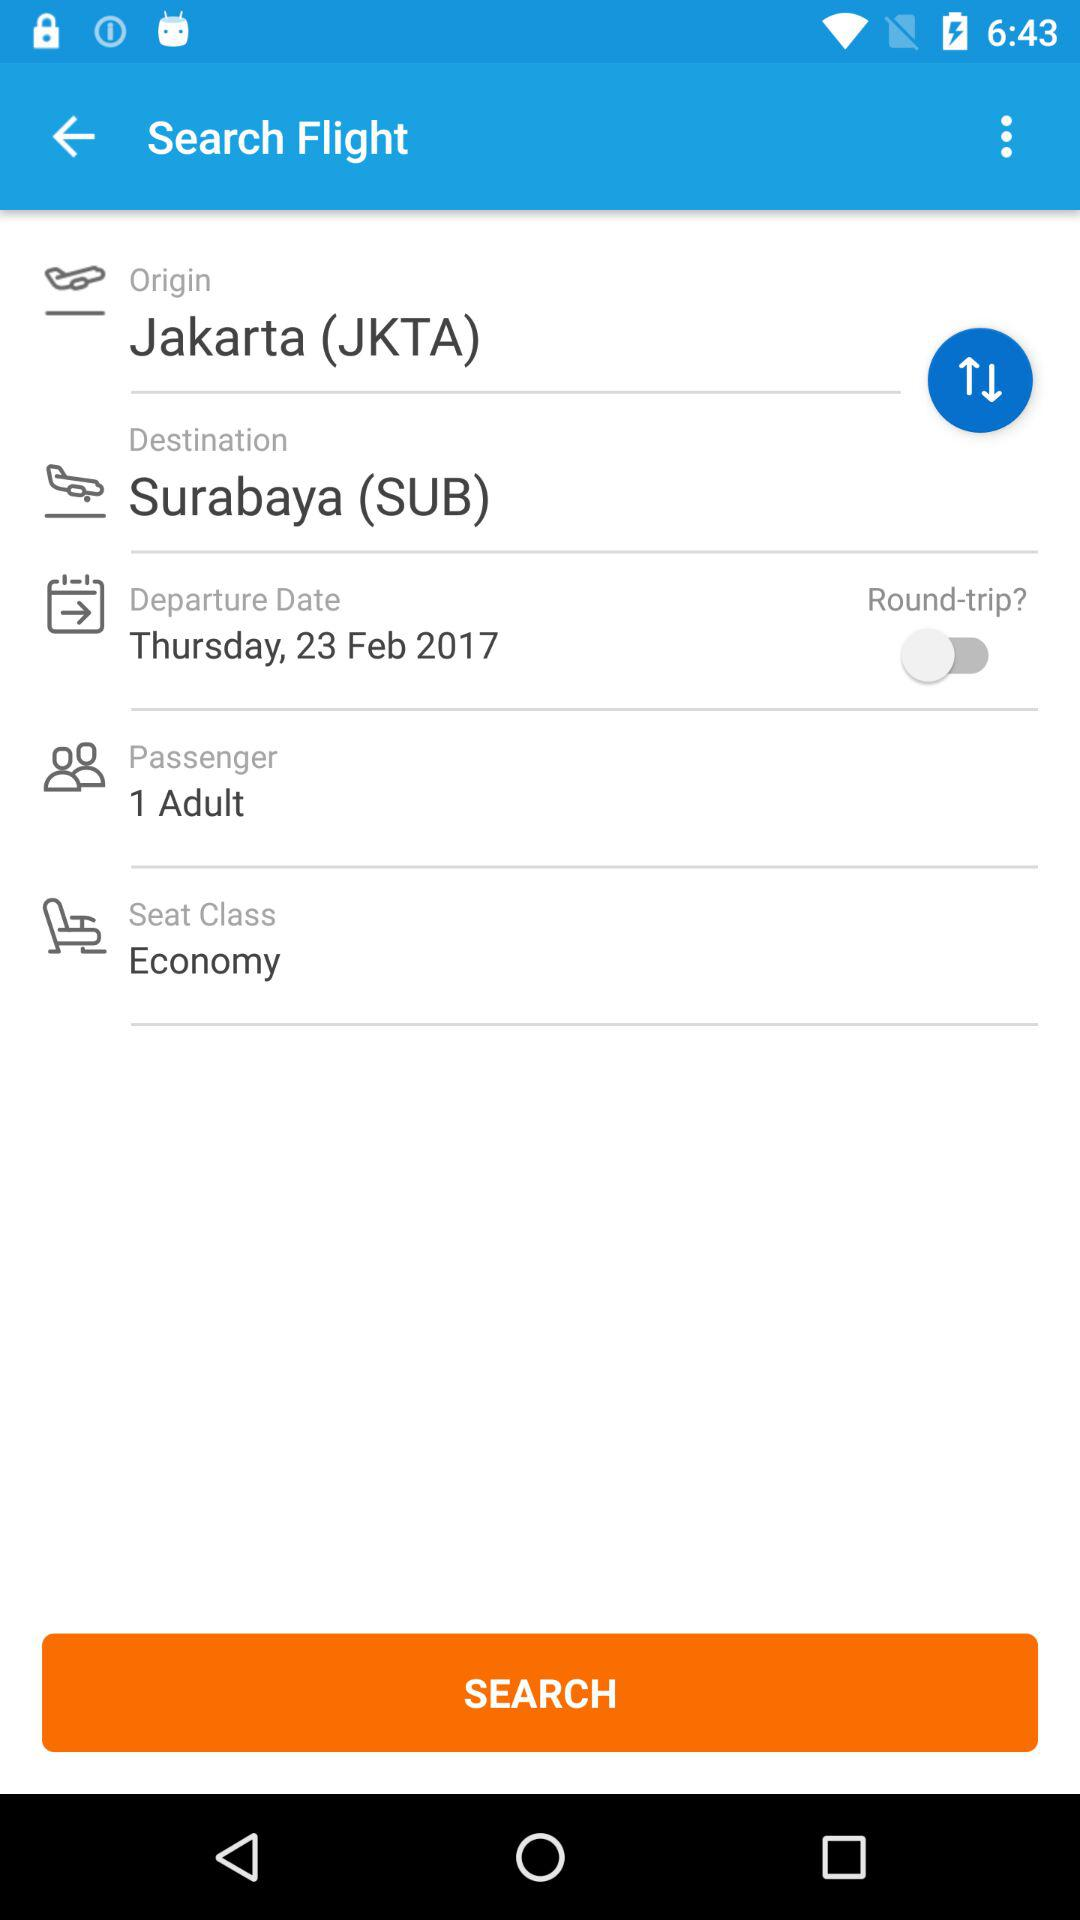What is the seat class? The class of the seat is economy. 